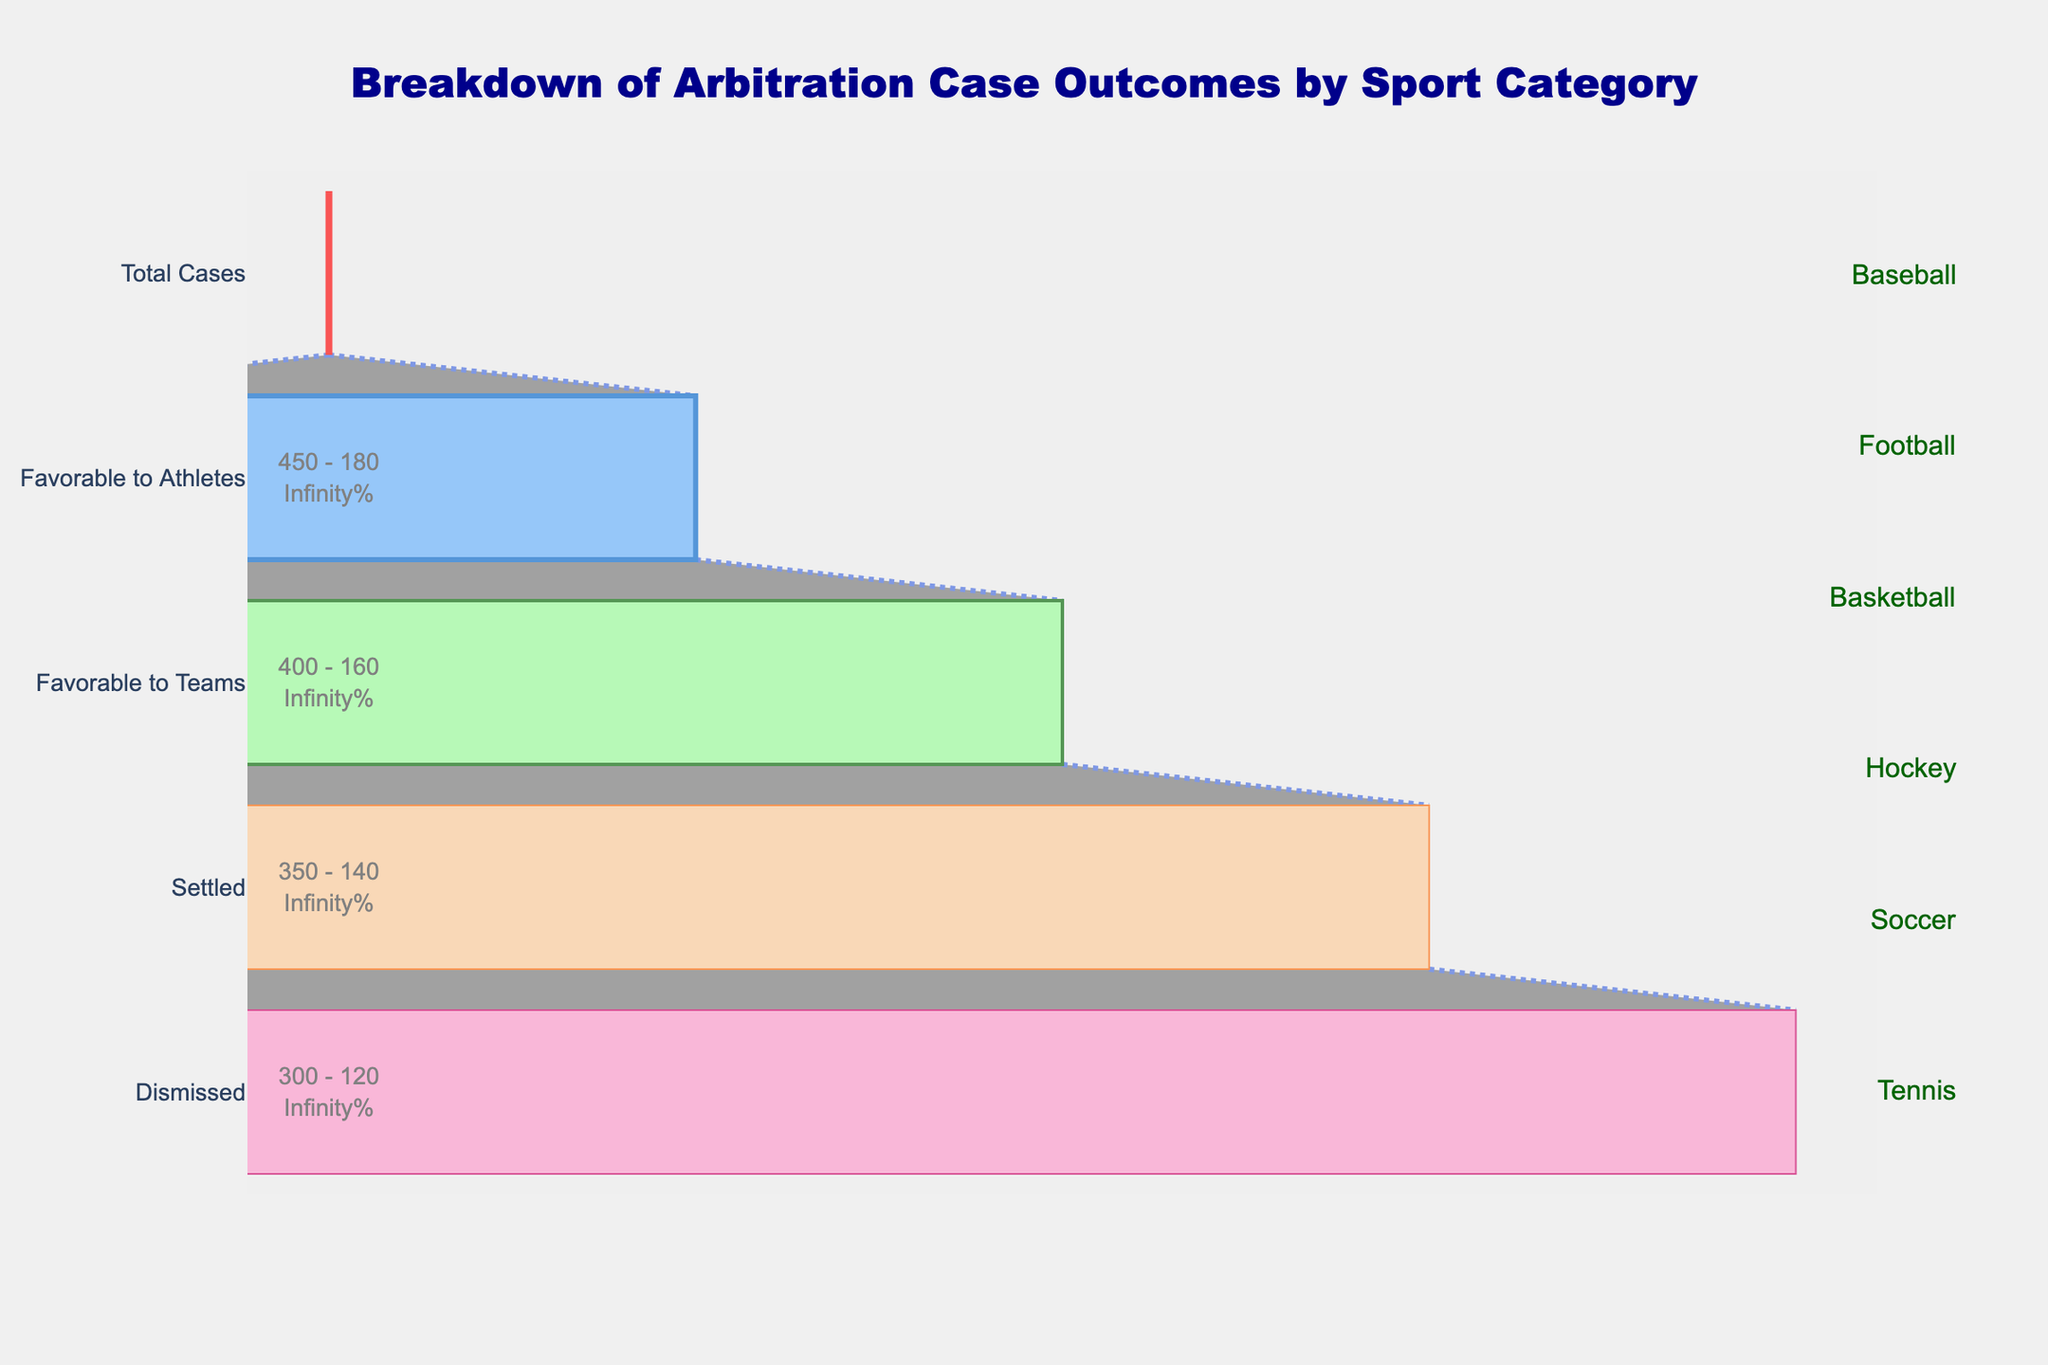How many total arbitration cases are there in baseball? To find this, look at the "Baseball" category and note the number of "Total Cases", which is 500.
Answer: 500 Which sport has the least number of total arbitration cases? Compare the "Total Cases" values for each sport; Soccer has the least with 300.
Answer: Soccer What percentage of total arbitration cases were favorable to athletes in football? Divide "Favorable to Athletes" cases by "Total Cases" for football and convert to a percentage: (180 / 450) * 100 = 40%.
Answer: 40% Which sport has more cases dismissed, basketball or hockey? Compare "Dismissed" cases in basketball and hockey: basketball has 40 and hockey has 35.
Answer: Basketball What is the overall number of arbitration cases that were settled across all sports? Sum the "Settled" cases for all sports: 100 + 90 + 80 + 70 + 60 + 50 = 450.
Answer: 450 How many favorable outcomes were there in hockey (both for athletes and teams combined)? Add "Favorable to Athletes" and "Favorable to Teams" cases in hockey: 140 + 105 = 245.
Answer: 245 Which sport has the highest ratio of favorable outcomes to total cases? Compute the ratio for each sport ((Favorable to Athletes + Favorable to Teams) / Total Cases) and compare:
Baseball: (200 + 150) / 500 = 0.70,
Football: (180 + 135) / 450 = 0.70,
Basketball: (160 + 120) / 400 = 0.70,
Hockey: (140 + 105) / 350 = 0.70,
Soccer: (120 + 90) / 300 = 0.70,
Tennis: (100 + 75) / 250 = 0.70;
All sports have the same ratio of 0.70.
Answer: All sports Which category (Favorable to Athletes, Favorable to Teams, Settled, Dismissed) has the smallest number of cases for all sports combined? Sum each category across all sports and identify the smallest:
Favorable to Athletes: 200 + 180 + 160 + 140 + 120 + 100 = 900,
Favorable to Teams: 150 + 135 + 120 + 105 + 90 + 75 = 675,
Settled: 100 + 90 + 80 + 70 + 60 + 50 = 450,
Dismissed: 50 + 45 + 40 + 35 + 30 + 25 = 225;
Dismissed is the smallest.
Answer: Dismissed What does the "Total Cases" segment represent in this Funnel Chart? The "Total Cases" segment represents the initial count of arbitration cases brought forth in each sport category before any decision outcomes are applied.
Answer: Initial count of cases By how much does the number of favorable cases for athletes exceed the number of cases that are settled in soccer? Subtract "Settled" cases from "Favorable to Athletes" in soccer: 120 - 60 = 60.
Answer: 60 